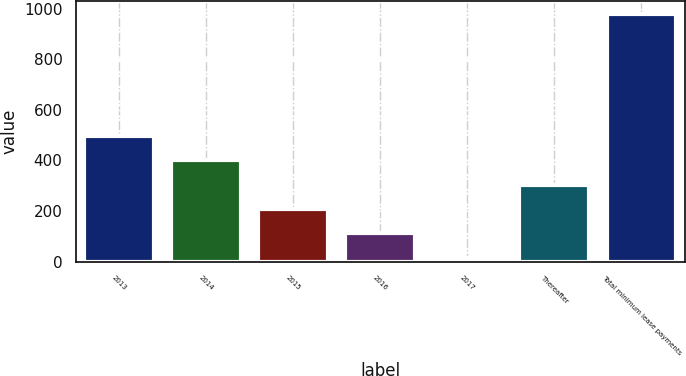Convert chart. <chart><loc_0><loc_0><loc_500><loc_500><bar_chart><fcel>2013<fcel>2014<fcel>2015<fcel>2016<fcel>2017<fcel>Thereafter<fcel>Total minimum lease payments<nl><fcel>497<fcel>400.6<fcel>207.8<fcel>111.4<fcel>15<fcel>304.2<fcel>979<nl></chart> 